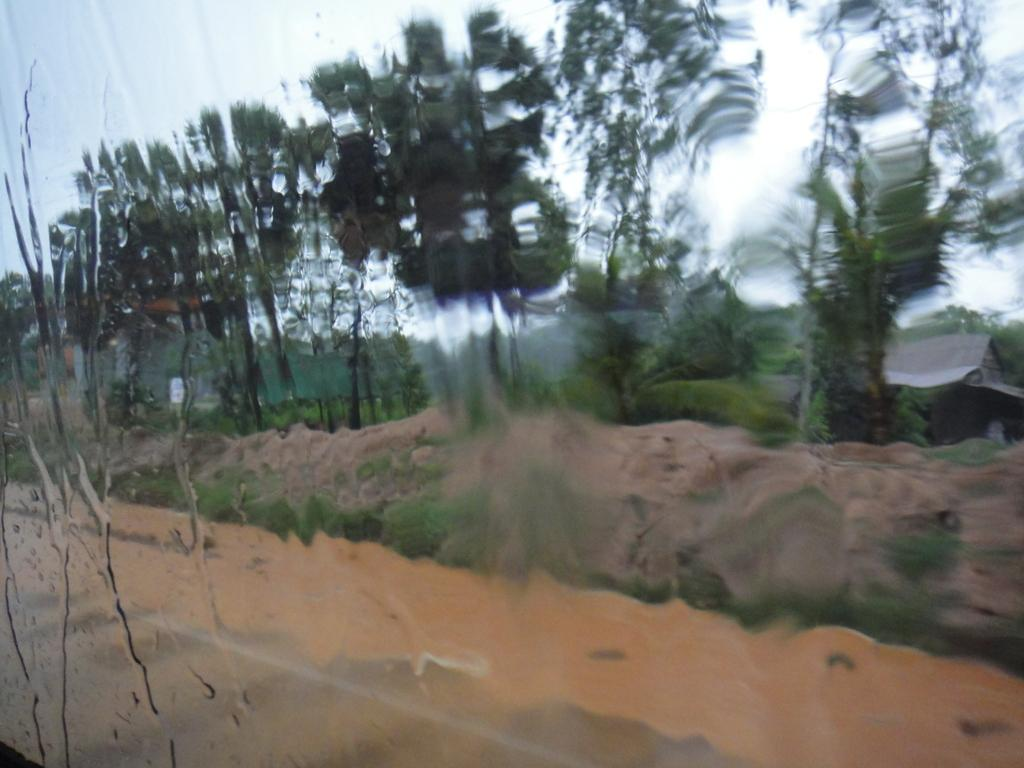What is on the transparent glass material in the image? There is water on a transparent glass material in the image. What type of vegetation can be seen in the image? There are plants and trees in the image. What is visible in the background of the image? The sky is visible in the background of the image. What type of plough is being used to cultivate the plants in the image? There is no plough present in the image; it features water on a transparent glass material, plants, trees, and the sky. What stage of growth are the plants in the image? The stage of growth of the plants cannot be determined from the image alone. 